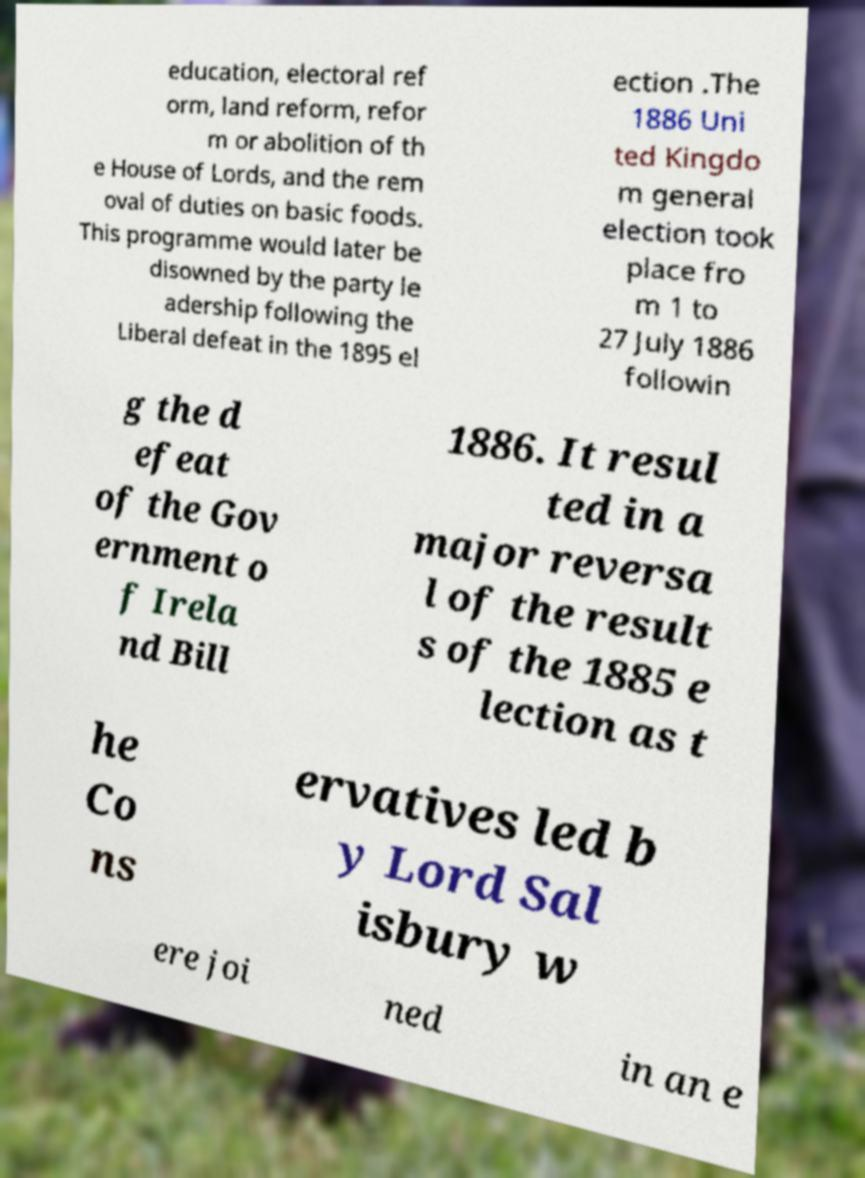Please read and relay the text visible in this image. What does it say? education, electoral ref orm, land reform, refor m or abolition of th e House of Lords, and the rem oval of duties on basic foods. This programme would later be disowned by the party le adership following the Liberal defeat in the 1895 el ection .The 1886 Uni ted Kingdo m general election took place fro m 1 to 27 July 1886 followin g the d efeat of the Gov ernment o f Irela nd Bill 1886. It resul ted in a major reversa l of the result s of the 1885 e lection as t he Co ns ervatives led b y Lord Sal isbury w ere joi ned in an e 